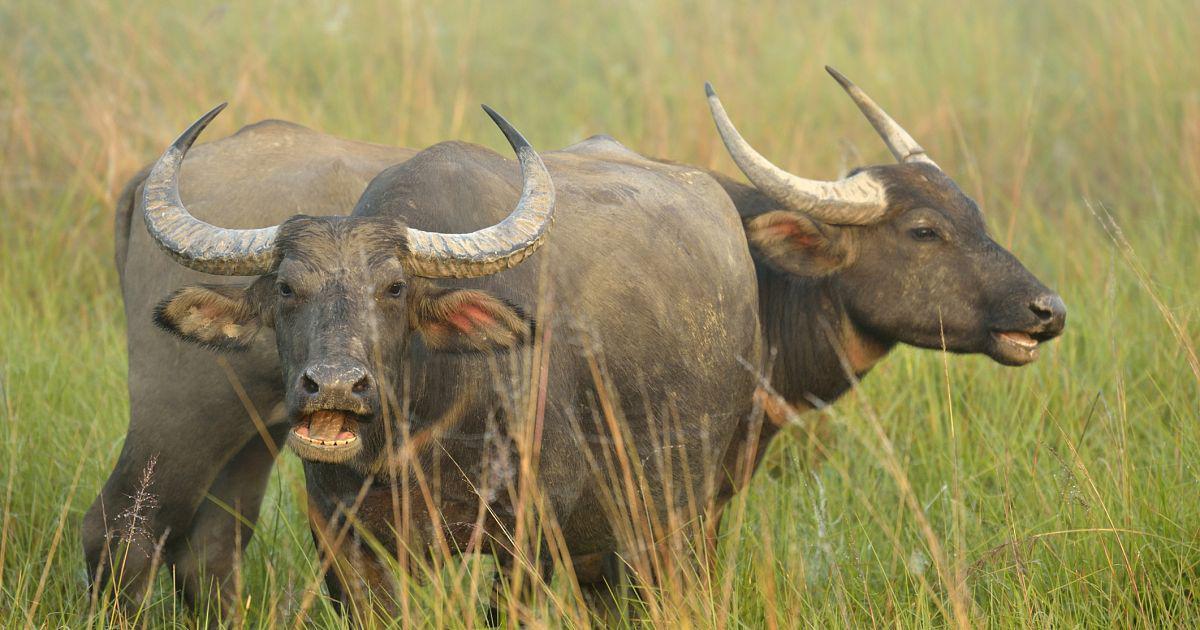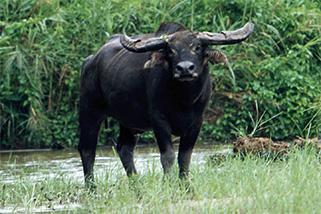The first image is the image on the left, the second image is the image on the right. Evaluate the accuracy of this statement regarding the images: "A body of water is visible in the right image of a water buffalo.". Is it true? Answer yes or no. Yes. The first image is the image on the left, the second image is the image on the right. Considering the images on both sides, is "There is a large black yak in the water." valid? Answer yes or no. Yes. 